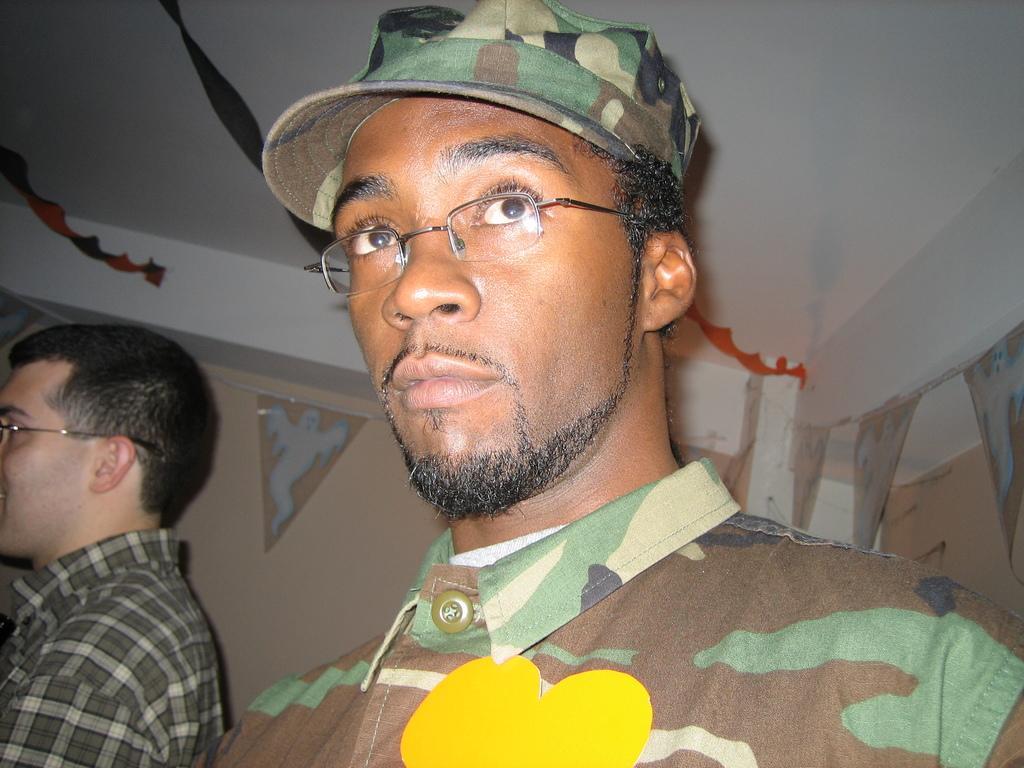Could you give a brief overview of what you see in this image? At the top we can see the ceiling. In this picture we can see the wall and few decorative objects. We can see a man wearing a shirt and spectacles. On the right side of the picture we can see a man wearing a cap, shirt and spectacles. 